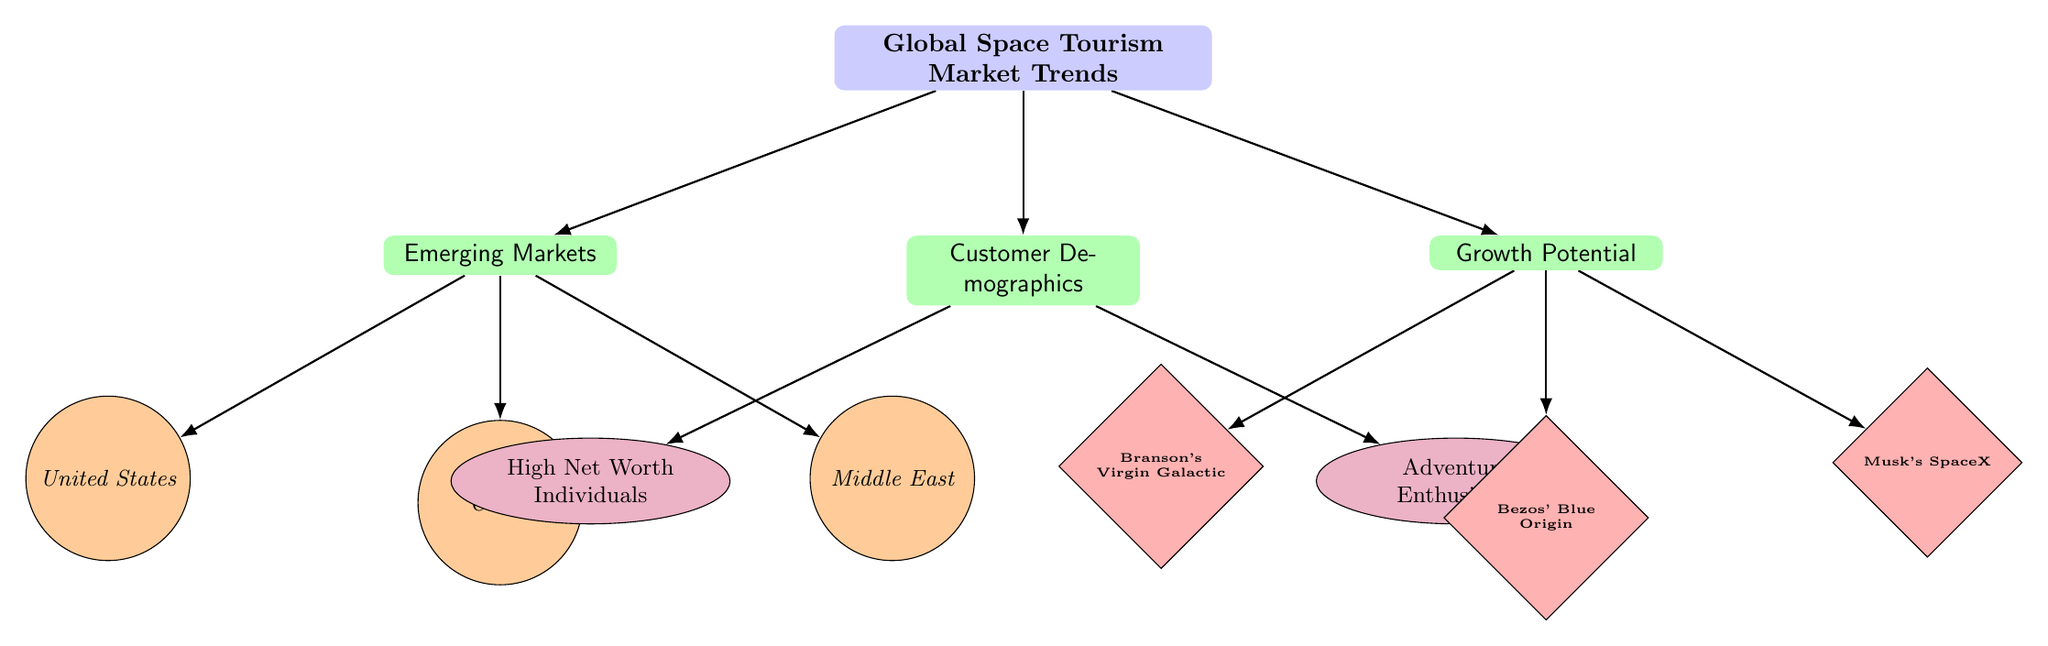What are the emerging markets identified in the diagram? The diagram lists three emerging markets under the "Emerging Markets" category: United States, China, and Middle East.
Answer: United States, China, Middle East Who are the customer demographics shown in the infographic? The demographics section includes two types of customers: High Net Worth Individuals and Adventure Enthusiasts.
Answer: High Net Worth Individuals, Adventure Enthusiasts Which companies are highlighted under growth potential? The growth potential category features three companies: Branson's Virgin Galactic, Bezos' Blue Origin, and Musk's SpaceX.
Answer: Branson's Virgin Galactic, Bezos' Blue Origin, Musk's SpaceX What is the relationship between the "Customer Demographics" and "High Net Worth Individuals"? The relationship is directly indicated by the connecting edge from "Customer Demographics" to "High Net Worth Individuals" in the diagram, showing that this group is one of the demographics considered in the market.
Answer: Direct connection How many nodes are associated with "Emerging Markets"? There are three nodes associated with "Emerging Markets": United States, China, and Middle East. Therefore, the total is three.
Answer: Three Which emerging market is positioned below the "Middle East"? According to the diagram, there is no market positioned directly below the Middle East node. The Middle East is the lowest node in its category.
Answer: None What type of customer is categorized as "Adventure Enthusiasts"? The type of customer categorized as Adventure Enthusiasts is indicated under the "Customer Demographics" category in the diagram.
Answer: Adventure Enthusiasts Which company is positioned directly below "Growth Potential"? The diagram indicates that "Blue Origin," associated with Bezos, is positioned directly below "Growth Potential."
Answer: Blue Origin What category does "High Net Worth Individuals" belong to? "High Net Worth Individuals" belongs to the "Customer Demographics" category, as shown in the diagram.
Answer: Customer Demographics 